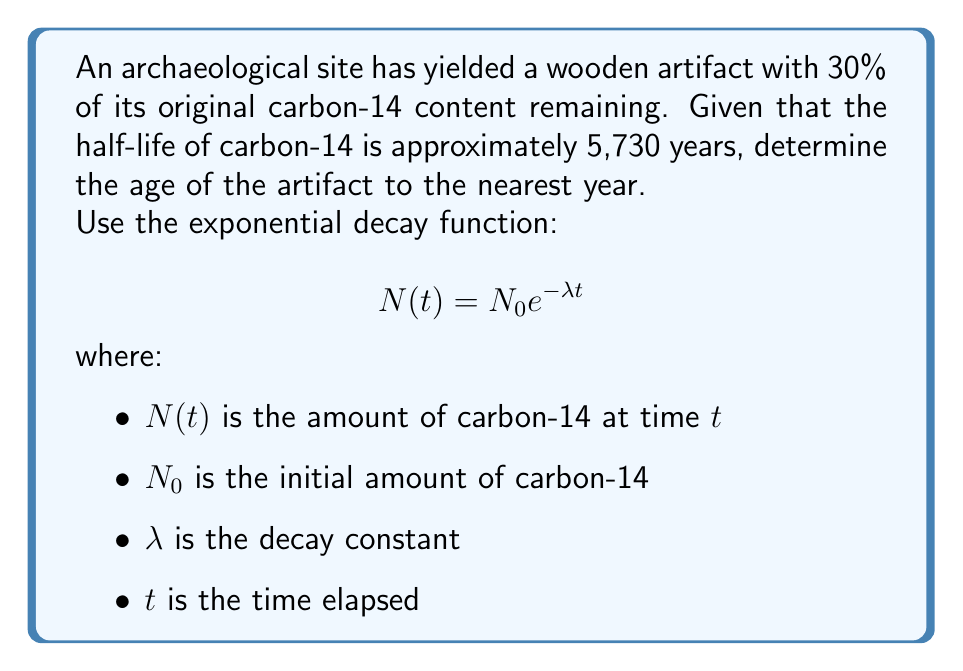Give your solution to this math problem. 1) First, we need to determine the decay constant $\lambda$. We can use the half-life formula:

   $$T_{1/2} = \frac{\ln(2)}{\lambda}$$

   Rearranging for $\lambda$:
   $$\lambda = \frac{\ln(2)}{T_{1/2}} = \frac{\ln(2)}{5730} \approx 0.000121$$

2) Now, we can use the exponential decay function:

   $$N(t) = N_0 e^{-\lambda t}$$

3) We know that 30% of the original carbon-14 remains, so:

   $$0.30 N_0 = N_0 e^{-0.000121t}$$

4) Divide both sides by $N_0$:

   $$0.30 = e^{-0.000121t}$$

5) Take the natural log of both sides:

   $$\ln(0.30) = -0.000121t$$

6) Solve for $t$:

   $$t = \frac{\ln(0.30)}{-0.000121} \approx 9967.8$$

7) Round to the nearest year:

   $$t \approx 9968 \text{ years}$$
Answer: 9968 years 